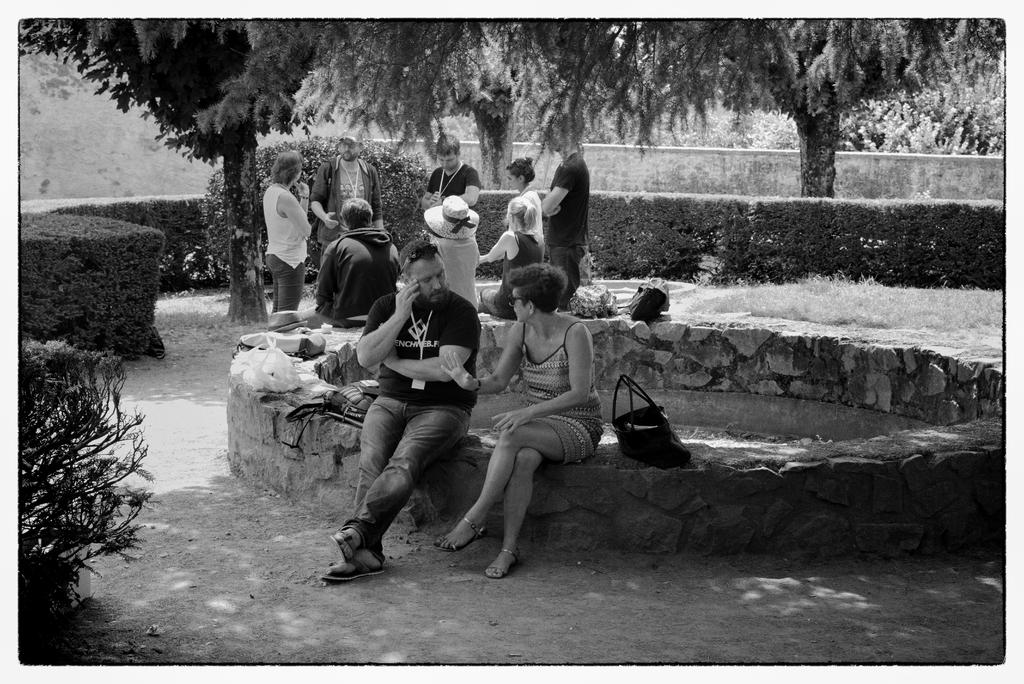What is the color scheme of the image? The image is black and white. What can be seen in terms of human presence in the image? There are people standing in the image. How many persons are sitting in the image? There are five persons sitting in the image. What type of vegetation is present in the image? There are plants and trees in the image. What time is displayed on the clock in the image? There is no clock present in the image. What type of curtain can be seen hanging from the window in the image? There is no window or curtain visible in the image. 